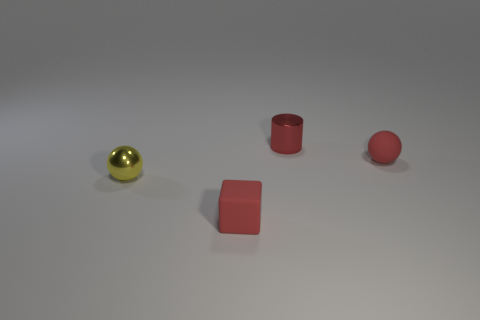What is the small red ball made of?
Give a very brief answer. Rubber. Is there a metal cylinder of the same size as the yellow thing?
Provide a short and direct response. Yes. There is a yellow thing that is the same size as the cylinder; what is its material?
Ensure brevity in your answer.  Metal. How many big brown cylinders are there?
Your answer should be compact. 0. Is the number of tiny red metal things in front of the small cylinder the same as the number of large balls?
Your answer should be compact. Yes. Is there a red metal object that has the same shape as the yellow shiny thing?
Make the answer very short. No. What is the shape of the object that is behind the cube and left of the small metal cylinder?
Your answer should be compact. Sphere. Does the tiny red block have the same material as the ball to the left of the shiny cylinder?
Provide a short and direct response. No. Are there any yellow shiny objects in front of the cylinder?
Your answer should be compact. Yes. How many objects are either tiny red rubber objects or red things that are right of the small red metallic object?
Keep it short and to the point. 2. 